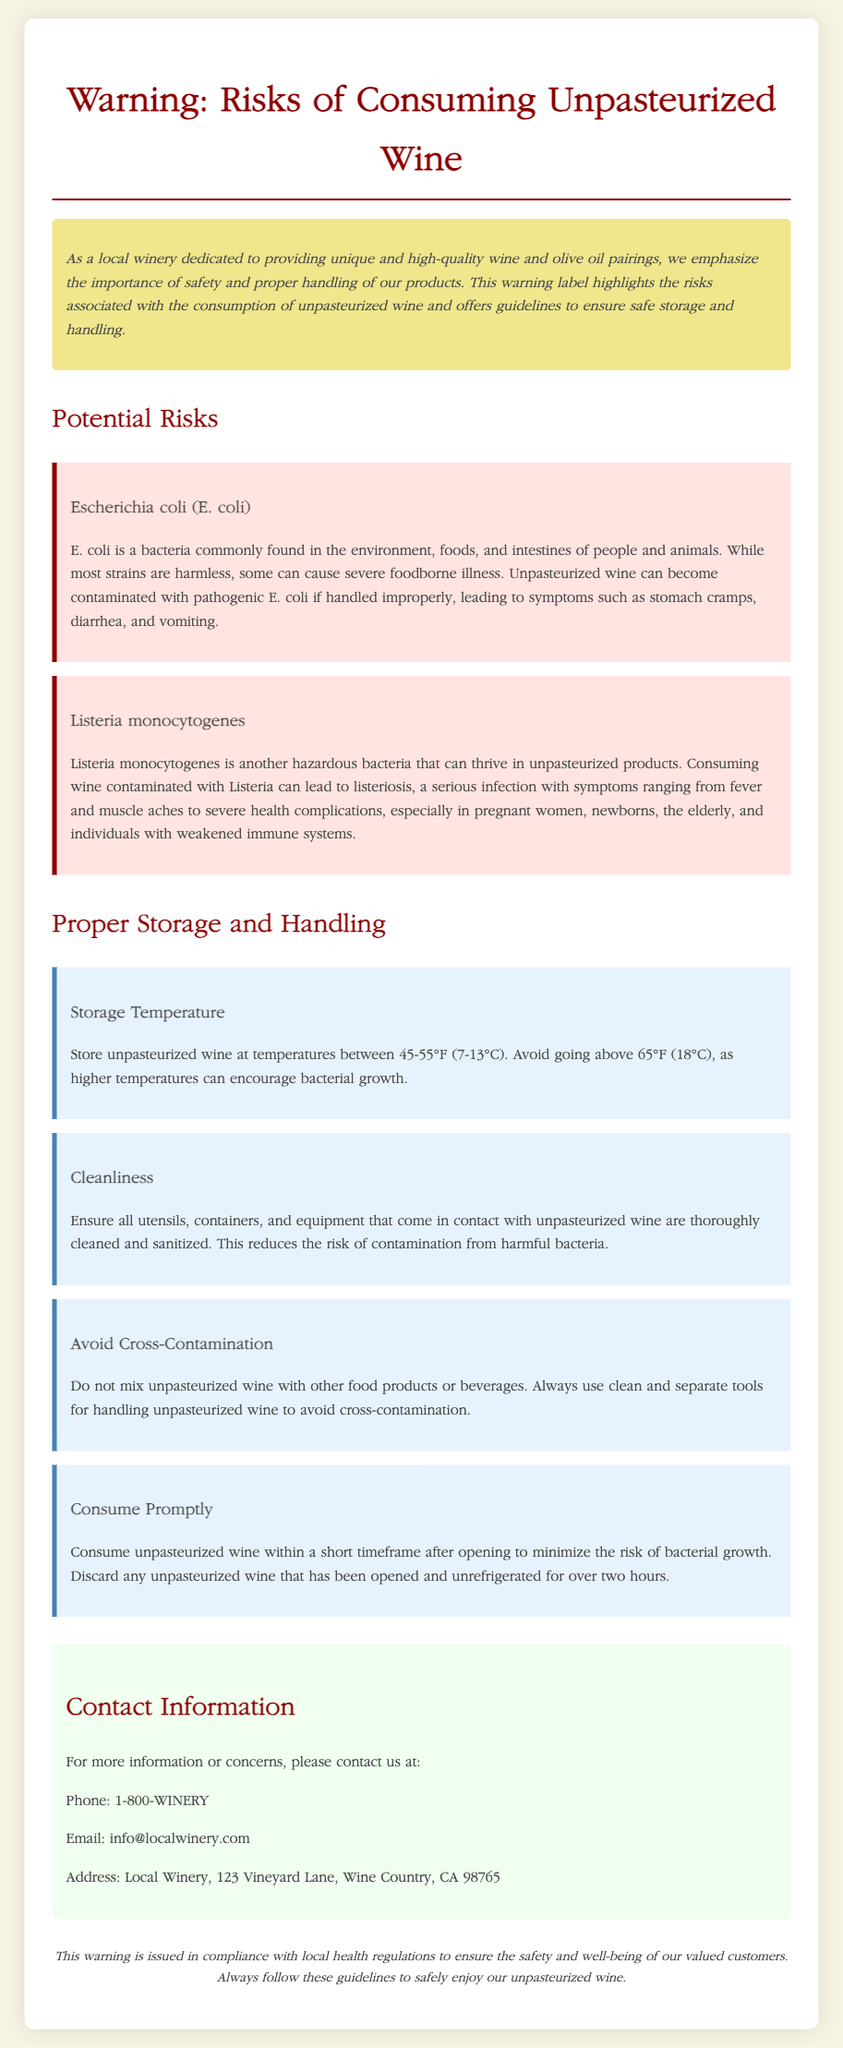What are the two bacteria mentioned in the document? The document specifically mentions Escherichia coli (E. coli) and Listeria monocytogenes as the two dangerous bacteria present in unpasteurized wine.
Answer: E. coli, Listeria monocytogenes What temperature should unpasteurized wine be stored at? The recommended storage temperature for unpasteurized wine is mentioned in the section on proper storage and handling, specifically stating it should be between 45-55°F.
Answer: 45-55°F What should you do with unpasteurized wine that has been opened for more than two hours? The document states you should discard any unpasteurized wine that has been opened and unrefrigerated for over two hours.
Answer: Discard it What is a symptom of E. coli infection mentioned in the document? The document lists stomach cramps, diarrhea, and vomiting as symptoms of E. coli infection.
Answer: Stomach cramps How can you minimize the risk of cross-contamination with unpasteurized wine? The document advises using clean and separate tools for handling unpasteurized wine to avoid cross-contamination.
Answer: Use clean and separate tools Which group is particularly at risk from Listeria monocytogenes? The document mentions that pregnant women, newborns, the elderly, and individuals with weakened immune systems are particularly at risk from Listeria monocytogenes.
Answer: Pregnant women What is recommended for cleanliness when handling unpasteurized wine? It is recommended to ensure all utensils, containers, and equipment that come in contact with unpasteurized wine are thoroughly cleaned and sanitized.
Answer: Clean and sanitize utensils What is the main purpose of this document? The main purpose of the document is to highlight the risks associated with consuming unpasteurized wine and to provide safety guidelines.
Answer: Safety guidelines 